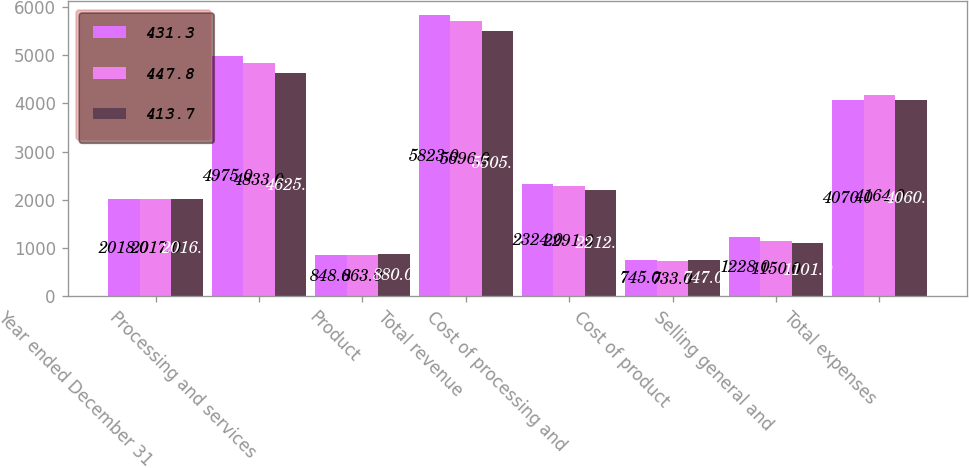<chart> <loc_0><loc_0><loc_500><loc_500><stacked_bar_chart><ecel><fcel>Year ended December 31<fcel>Processing and services<fcel>Product<fcel>Total revenue<fcel>Cost of processing and<fcel>Cost of product<fcel>Selling general and<fcel>Total expenses<nl><fcel>431.3<fcel>2018<fcel>4975<fcel>848<fcel>5823<fcel>2324<fcel>745<fcel>1228<fcel>4070<nl><fcel>447.8<fcel>2017<fcel>4833<fcel>863<fcel>5696<fcel>2291<fcel>733<fcel>1150<fcel>4164<nl><fcel>413.7<fcel>2016<fcel>4625<fcel>880<fcel>5505<fcel>2212<fcel>747<fcel>1101<fcel>4060<nl></chart> 